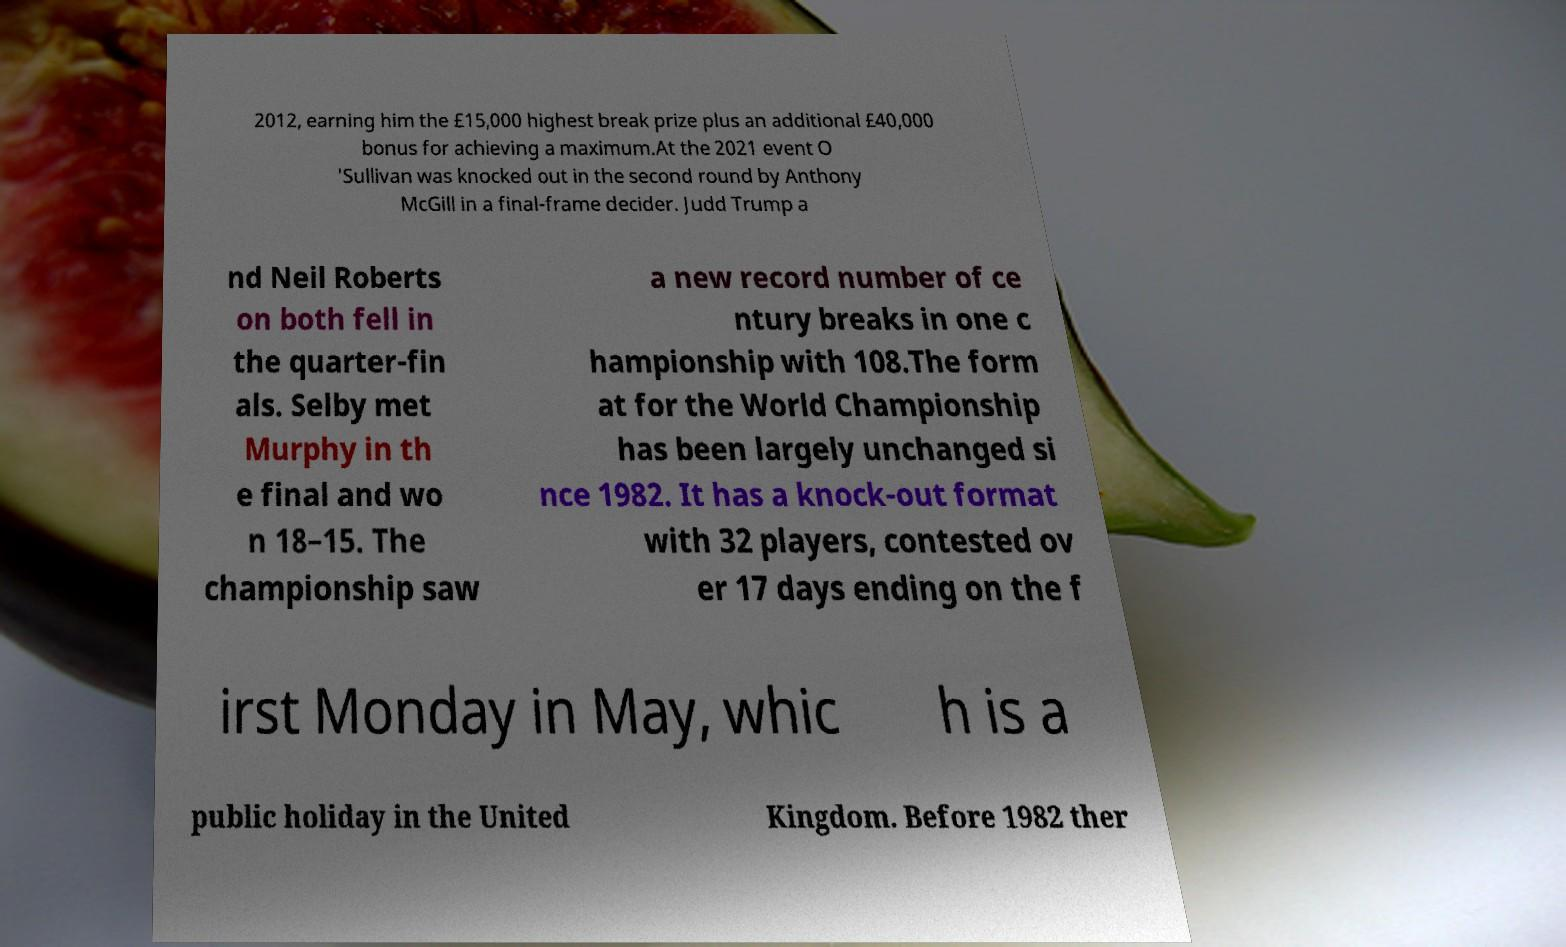Can you accurately transcribe the text from the provided image for me? 2012, earning him the £15,000 highest break prize plus an additional £40,000 bonus for achieving a maximum.At the 2021 event O 'Sullivan was knocked out in the second round by Anthony McGill in a final-frame decider. Judd Trump a nd Neil Roberts on both fell in the quarter-fin als. Selby met Murphy in th e final and wo n 18–15. The championship saw a new record number of ce ntury breaks in one c hampionship with 108.The form at for the World Championship has been largely unchanged si nce 1982. It has a knock-out format with 32 players, contested ov er 17 days ending on the f irst Monday in May, whic h is a public holiday in the United Kingdom. Before 1982 ther 